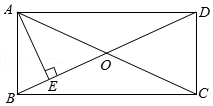Elaborate on what is shown in the illustration. The diagram shows a rectangle with vertices labeled A, B, C, and D. Point O is the intersection of the diagonals AC and BD. A perpendicular line AE is drawn from point A to intersect with the diagonal BD. 